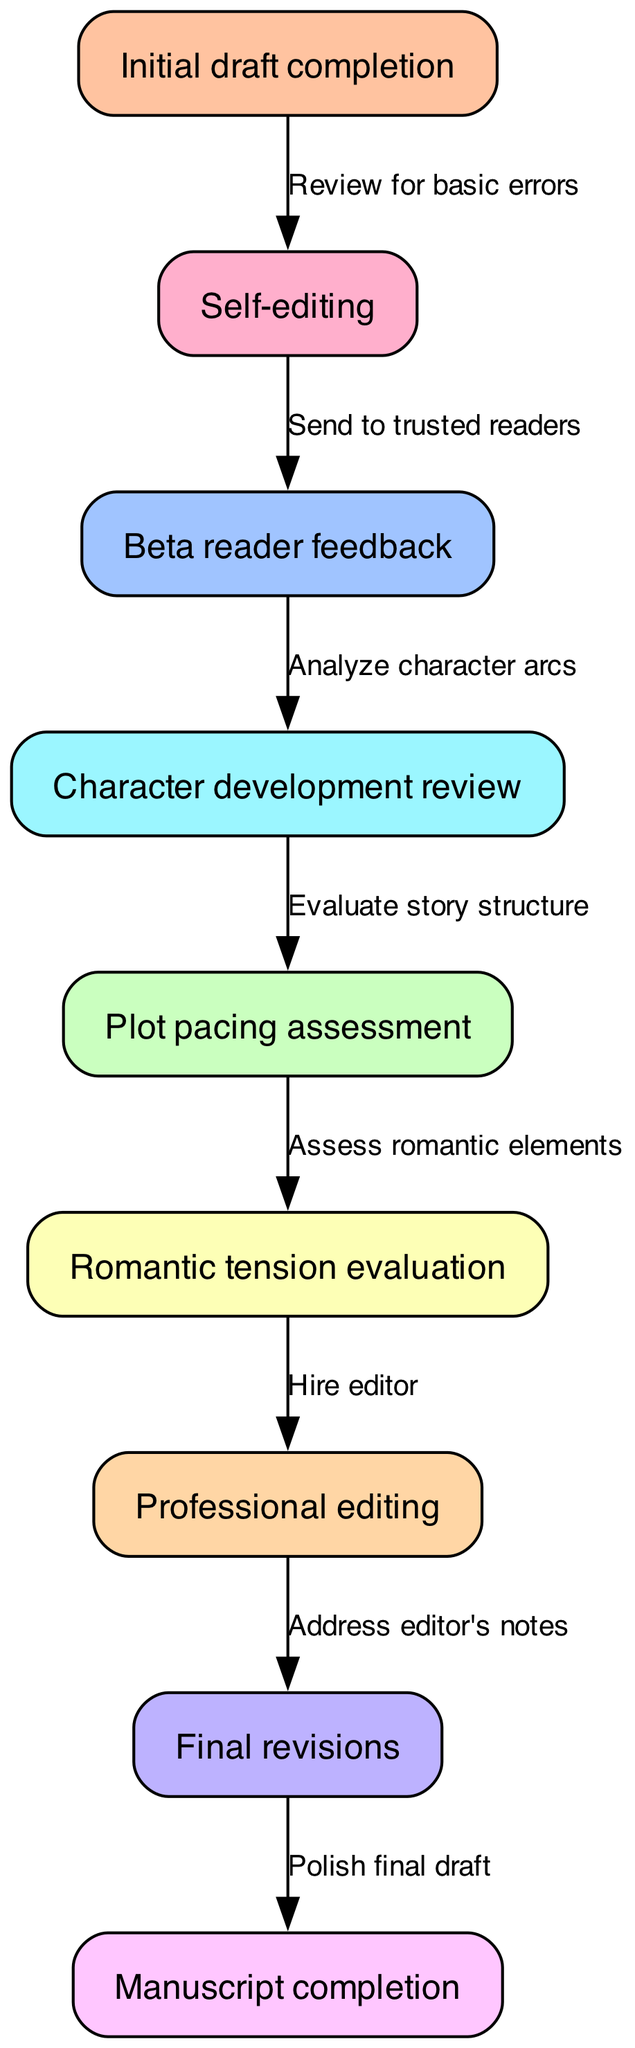What is the first step in the revision workflow? The first node in the diagram is "Initial draft completion," indicating it is the starting point of the workflow.
Answer: Initial draft completion How many nodes are there in the diagram? By counting all the individual nodes listed in the "nodes" section, there are a total of nine nodes, each representing a step in the workflow.
Answer: 9 What comes after self-editing? Looking at the edges connecting the nodes, after "Self-editing," the next step is "Beta reader feedback," which indicates that this is the following action in the workflow.
Answer: Beta reader feedback Which step involves hiring an editor? The edge connecting "Romantic tension evaluation" to "Professional editing" shows that this is the step where hiring an editor takes place in the workflow.
Answer: Hire editor What is the relationship between plot pacing assessment and romantic tension evaluation? The diagram indicates a sequence where "Plot pacing assessment" directly precedes "Romantic tension evaluation," suggesting that the assessment of plot pacing is a step leading to the evaluation of romantic tension.
Answer: Assess romantic elements What are the last two steps in this workflow? By examining the nodes at the end of the diagram, the final two steps are "Final revisions" followed by "Manuscript completion," indicating the conclusion of the workflow process.
Answer: Final revisions, Manuscript completion What feedback is analyzed after beta reader feedback? The process specified in the diagram states that "Beta reader feedback" leads to "Character development review," showing that this is the feedback that gets analyzed next.
Answer: Analyze character arcs How do revisions based on professional editing conclude? The edge leading from "Professional editing" to "Final revisions" indicates that this is where revisions are conducted based on the feedback received from the professional editor.
Answer: Address editor's notes 